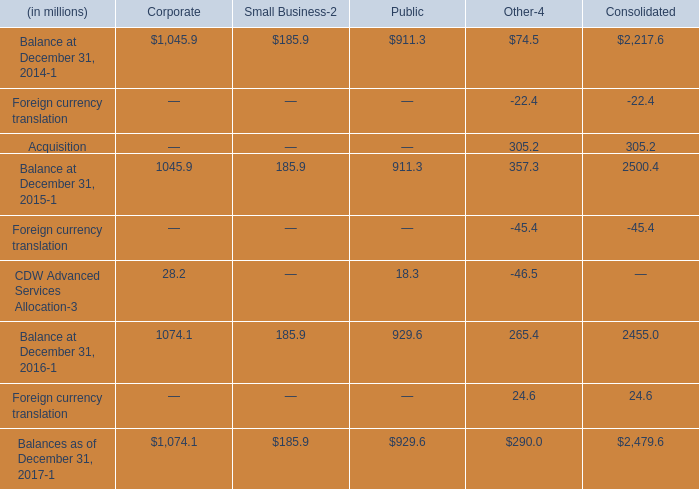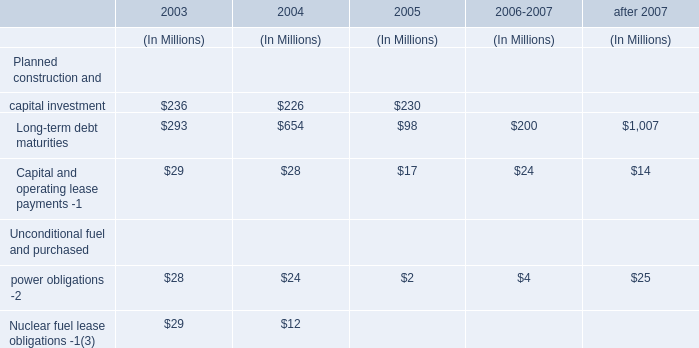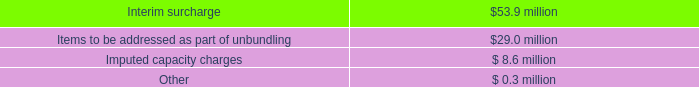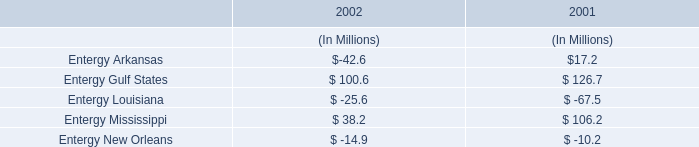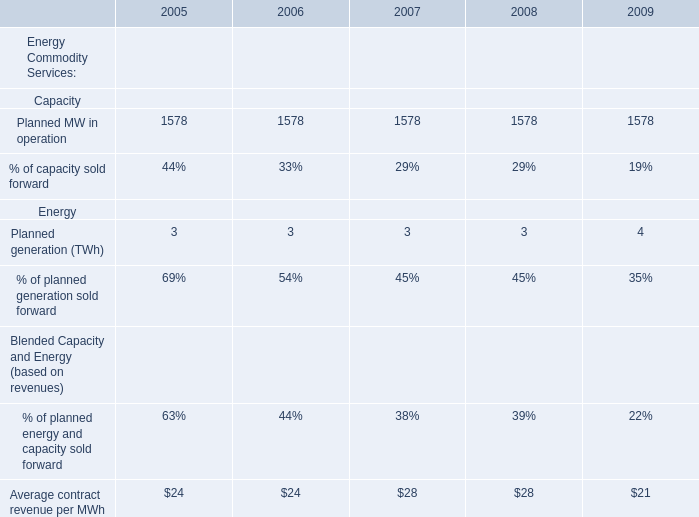What will Planned generation (TWh) be like in 2010 if it continues to grow at the same rate as it did in 2009? 
Computations: (4 * (1 + ((4 - 3) / 3)))
Answer: 5.33333. 